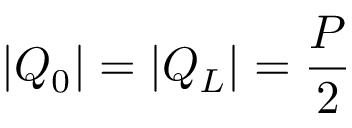Convert formula to latex. <formula><loc_0><loc_0><loc_500><loc_500>| Q _ { 0 } | = | Q _ { L } | = { \frac { P } { 2 } }</formula> 